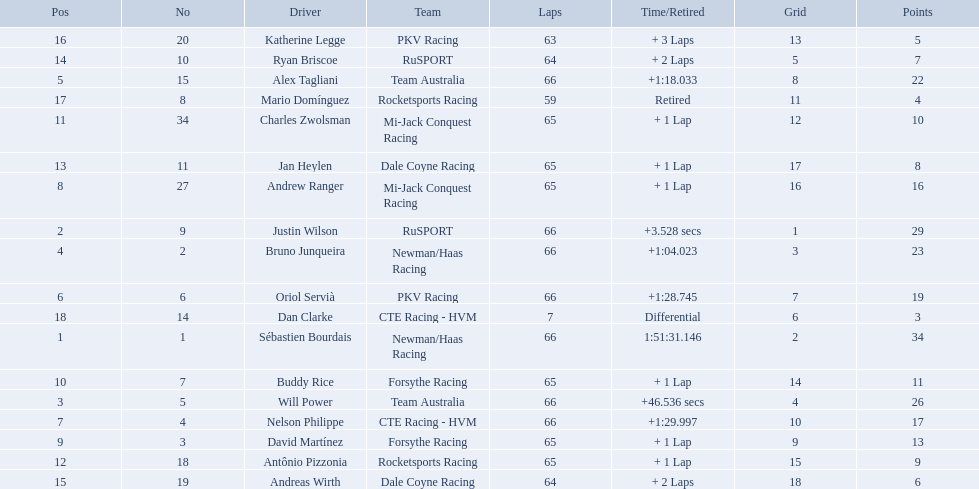Which people scored 29+ points? Sébastien Bourdais, Justin Wilson. Who scored higher? Sébastien Bourdais. What are the names of the drivers who were in position 14 through position 18? Ryan Briscoe, Andreas Wirth, Katherine Legge, Mario Domínguez, Dan Clarke. Of these , which ones didn't finish due to retired or differential? Mario Domínguez, Dan Clarke. Which one of the previous drivers retired? Mario Domínguez. Which of the drivers in question 2 had a differential? Dan Clarke. 